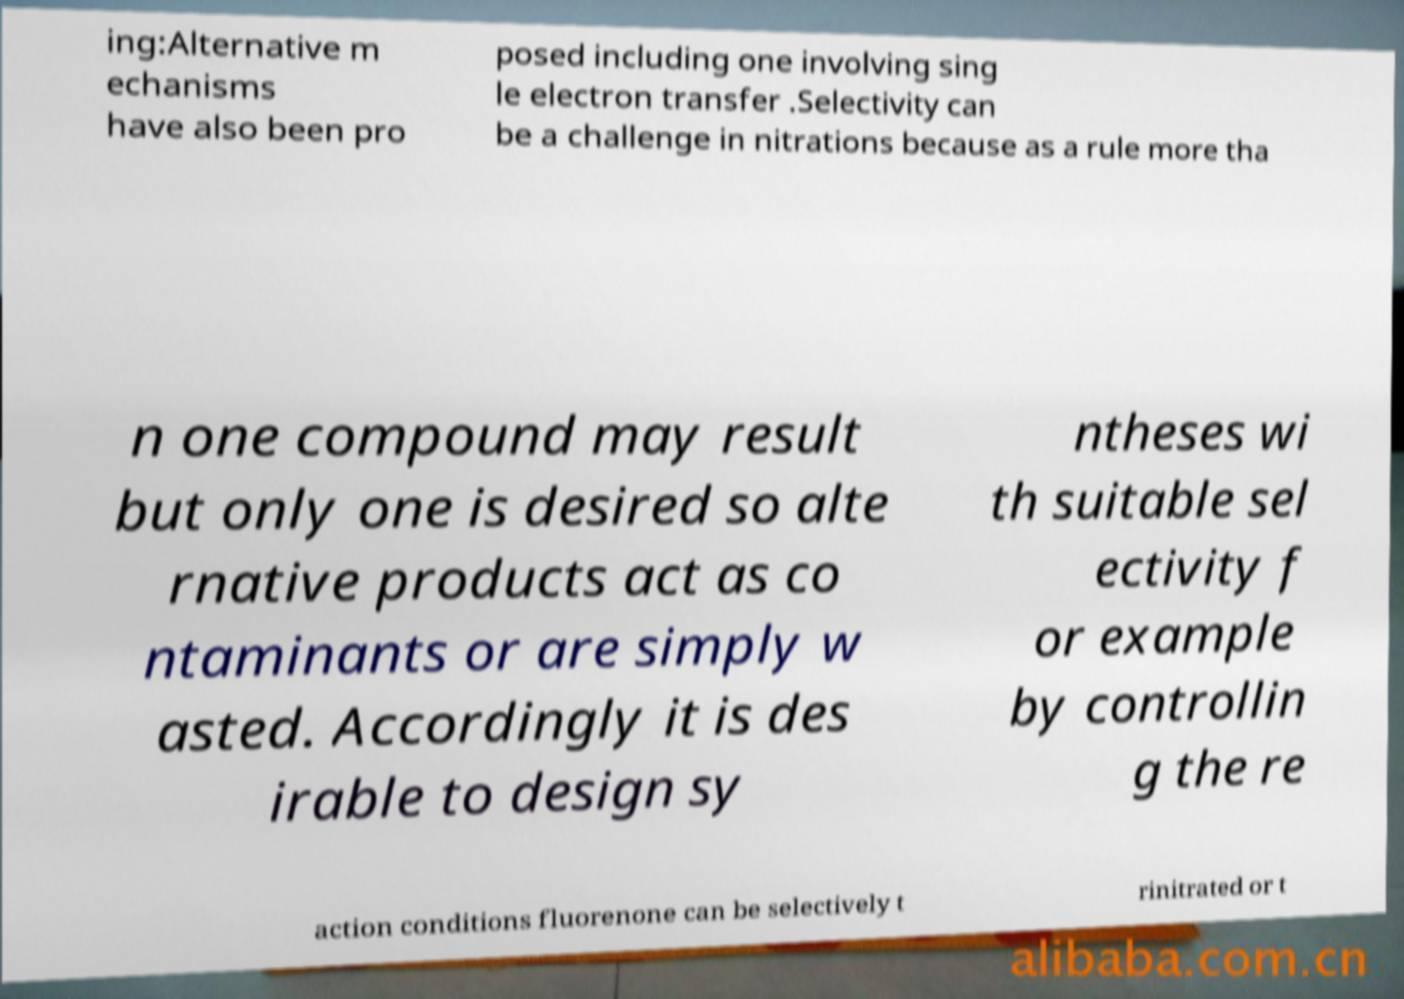What messages or text are displayed in this image? I need them in a readable, typed format. ing:Alternative m echanisms have also been pro posed including one involving sing le electron transfer .Selectivity can be a challenge in nitrations because as a rule more tha n one compound may result but only one is desired so alte rnative products act as co ntaminants or are simply w asted. Accordingly it is des irable to design sy ntheses wi th suitable sel ectivity f or example by controllin g the re action conditions fluorenone can be selectively t rinitrated or t 